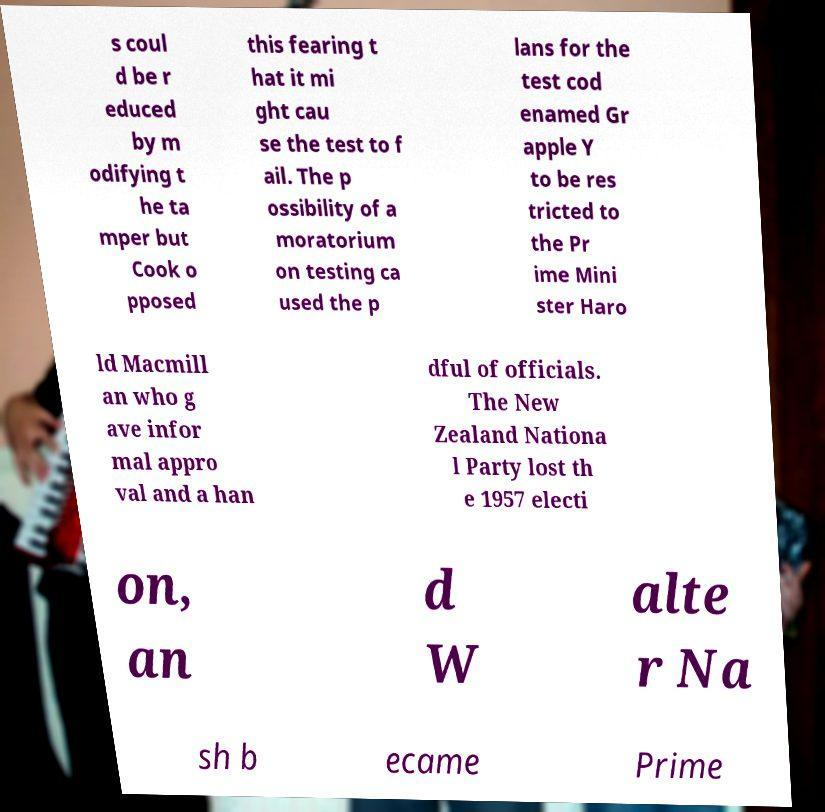Can you accurately transcribe the text from the provided image for me? s coul d be r educed by m odifying t he ta mper but Cook o pposed this fearing t hat it mi ght cau se the test to f ail. The p ossibility of a moratorium on testing ca used the p lans for the test cod enamed Gr apple Y to be res tricted to the Pr ime Mini ster Haro ld Macmill an who g ave infor mal appro val and a han dful of officials. The New Zealand Nationa l Party lost th e 1957 electi on, an d W alte r Na sh b ecame Prime 